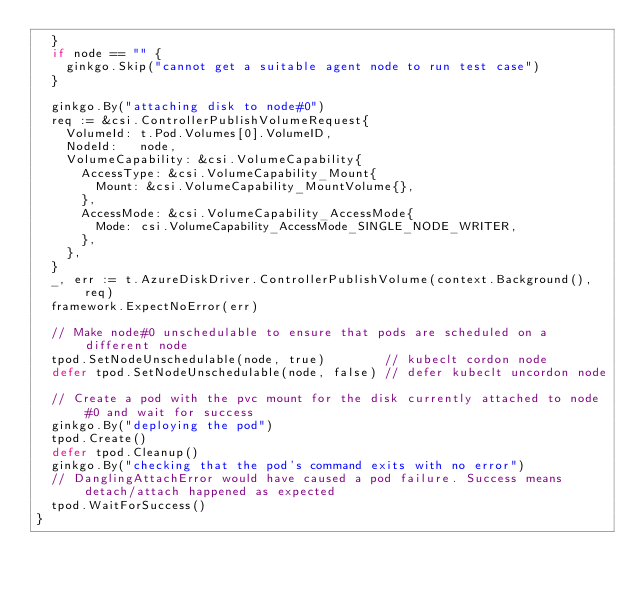Convert code to text. <code><loc_0><loc_0><loc_500><loc_500><_Go_>	}
	if node == "" {
		ginkgo.Skip("cannot get a suitable agent node to run test case")
	}

	ginkgo.By("attaching disk to node#0")
	req := &csi.ControllerPublishVolumeRequest{
		VolumeId: t.Pod.Volumes[0].VolumeID,
		NodeId:   node,
		VolumeCapability: &csi.VolumeCapability{
			AccessType: &csi.VolumeCapability_Mount{
				Mount: &csi.VolumeCapability_MountVolume{},
			},
			AccessMode: &csi.VolumeCapability_AccessMode{
				Mode: csi.VolumeCapability_AccessMode_SINGLE_NODE_WRITER,
			},
		},
	}
	_, err := t.AzureDiskDriver.ControllerPublishVolume(context.Background(), req)
	framework.ExpectNoError(err)

	// Make node#0 unschedulable to ensure that pods are scheduled on a different node
	tpod.SetNodeUnschedulable(node, true)        // kubeclt cordon node
	defer tpod.SetNodeUnschedulable(node, false) // defer kubeclt uncordon node

	// Create a pod with the pvc mount for the disk currently attached to node#0 and wait for success
	ginkgo.By("deploying the pod")
	tpod.Create()
	defer tpod.Cleanup()
	ginkgo.By("checking that the pod's command exits with no error")
	// DanglingAttachError would have caused a pod failure. Success means detach/attach happened as expected
	tpod.WaitForSuccess()
}
</code> 